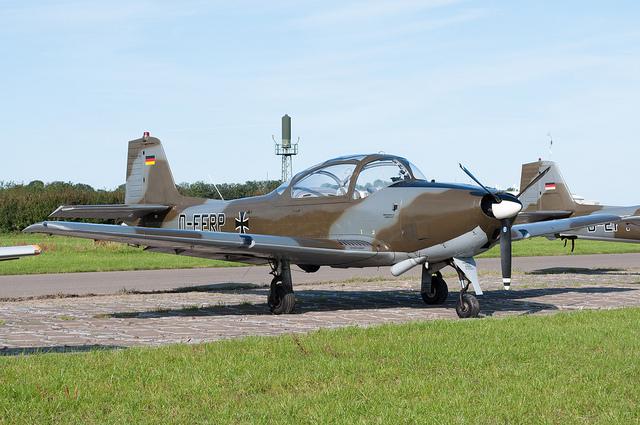What is the black and white symbol on the plane?
Give a very brief answer. Cross. Is this plane in the air?
Give a very brief answer. No. Is this an historical plane?
Give a very brief answer. Yes. 